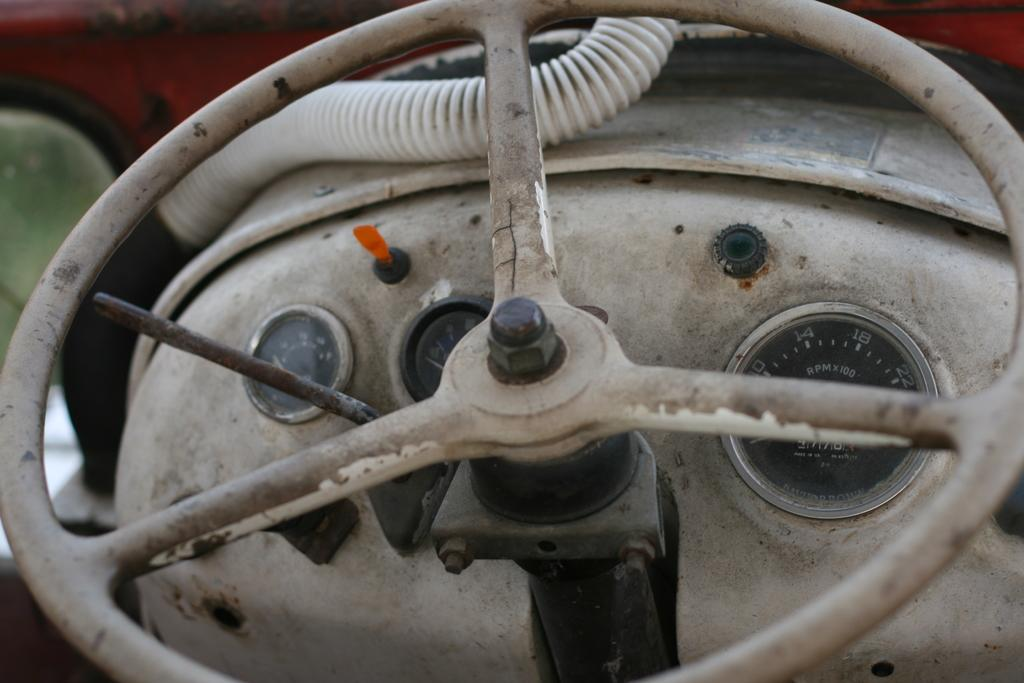What is the primary control element visible in the image? There is a steering wheel in the image. What instrument is used to measure the speed of the vehicle in the image? There are speedometers in the image. Based on the presence of a steering wheel and speedometers, what type of vehicle might be depicted in the image? It is reasonable to assume that the image depicts a vehicle, such as a car or truck, given the presence of a steering wheel and speedometers. What type of grain is being harvested in the image? There is no grain or harvesting activity present in the image; it features a steering wheel and speedometers, which are commonly found in vehicles. 